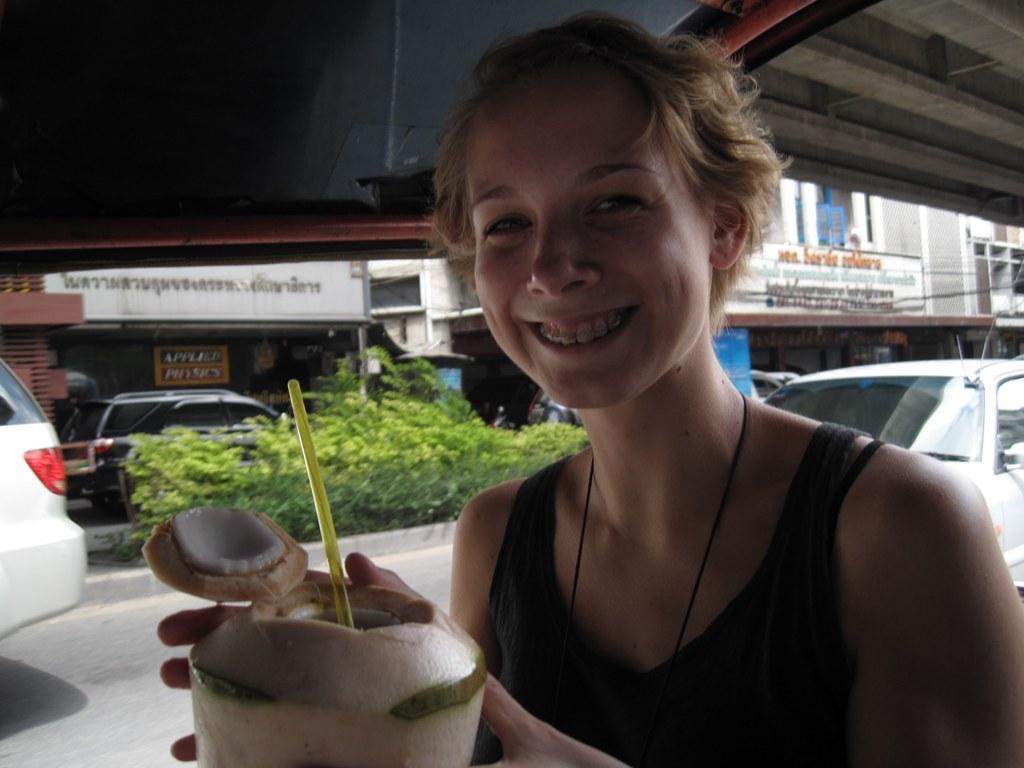Can you describe this image briefly? In this image we can see a lady holding a tender coconut with straw. In the back there are plants and vehicles. Also there are buildings with name boards. 